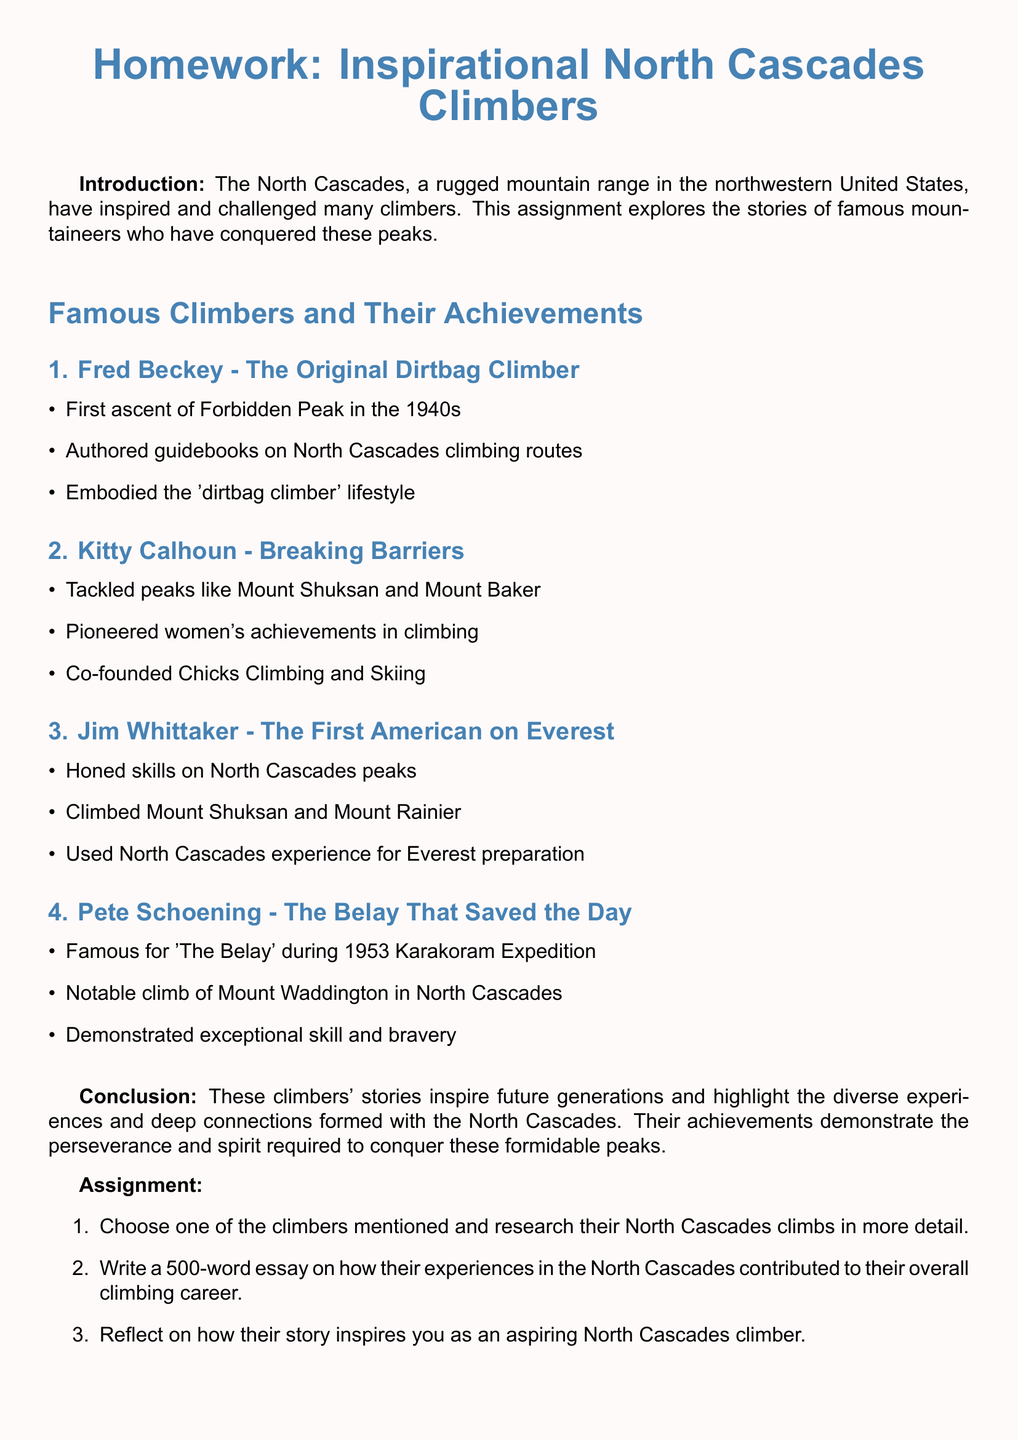What did Fred Beckey do in the 1940s? Fred Beckey was known for the first ascent of Forbidden Peak in the 1940s.
Answer: First ascent of Forbidden Peak What did Kitty Calhoun co-found? Kitty Calhoun co-founded Chicks Climbing and Skiing, which promotes women's climbing achievements.
Answer: Chicks Climbing and Skiing What notable climb did Jim Whittaker accomplish? Jim Whittaker climbed Mount Shuksan and Mount Rainier, which he honed his skills on.
Answer: Mount Shuksan and Mount Rainier What is Pete Schoening famous for? Pete Schoening is famous for 'The Belay' during the 1953 Karakoram Expedition.
Answer: 'The Belay' How did the North Cascades influence Jim Whittaker's Everest preparation? Jim Whittaker used his experience in the North Cascades as preparation for climbing Everest.
Answer: Preparation for Everest Which climber is known as the original dirtbag climber? Fred Beckey is referred to as the original dirtbag climber in the document.
Answer: Fred Beckey What type of climbing achievements does the assignment encourage students to reflect on? The assignment encourages students to reflect on how the climbers' stories inspire them as aspiring climbers in the North Cascades.
Answer: Inspire aspiring climbers What document type is this homework classified as? This document is classified as a homework assignment focused on famous climbers.
Answer: Homework assignment 